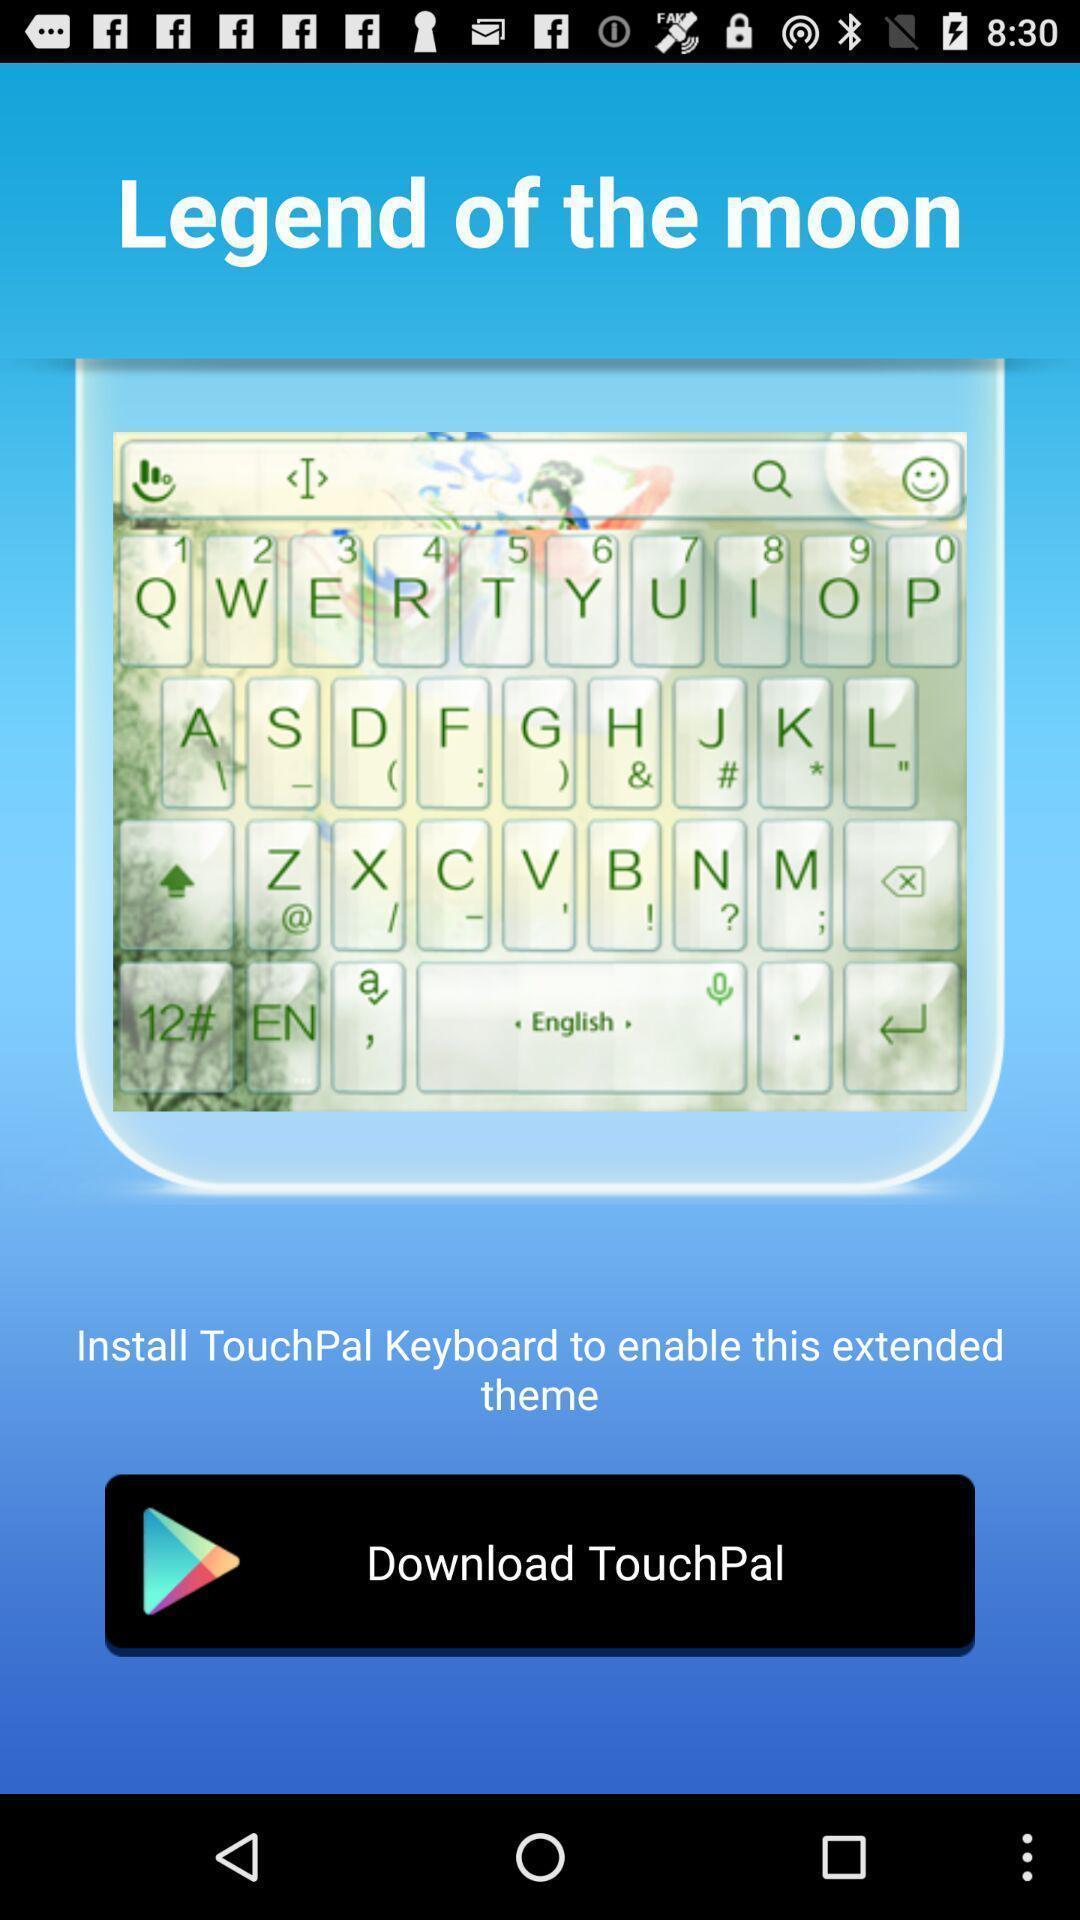Summarize the main components in this picture. Screen showing page with download option. 